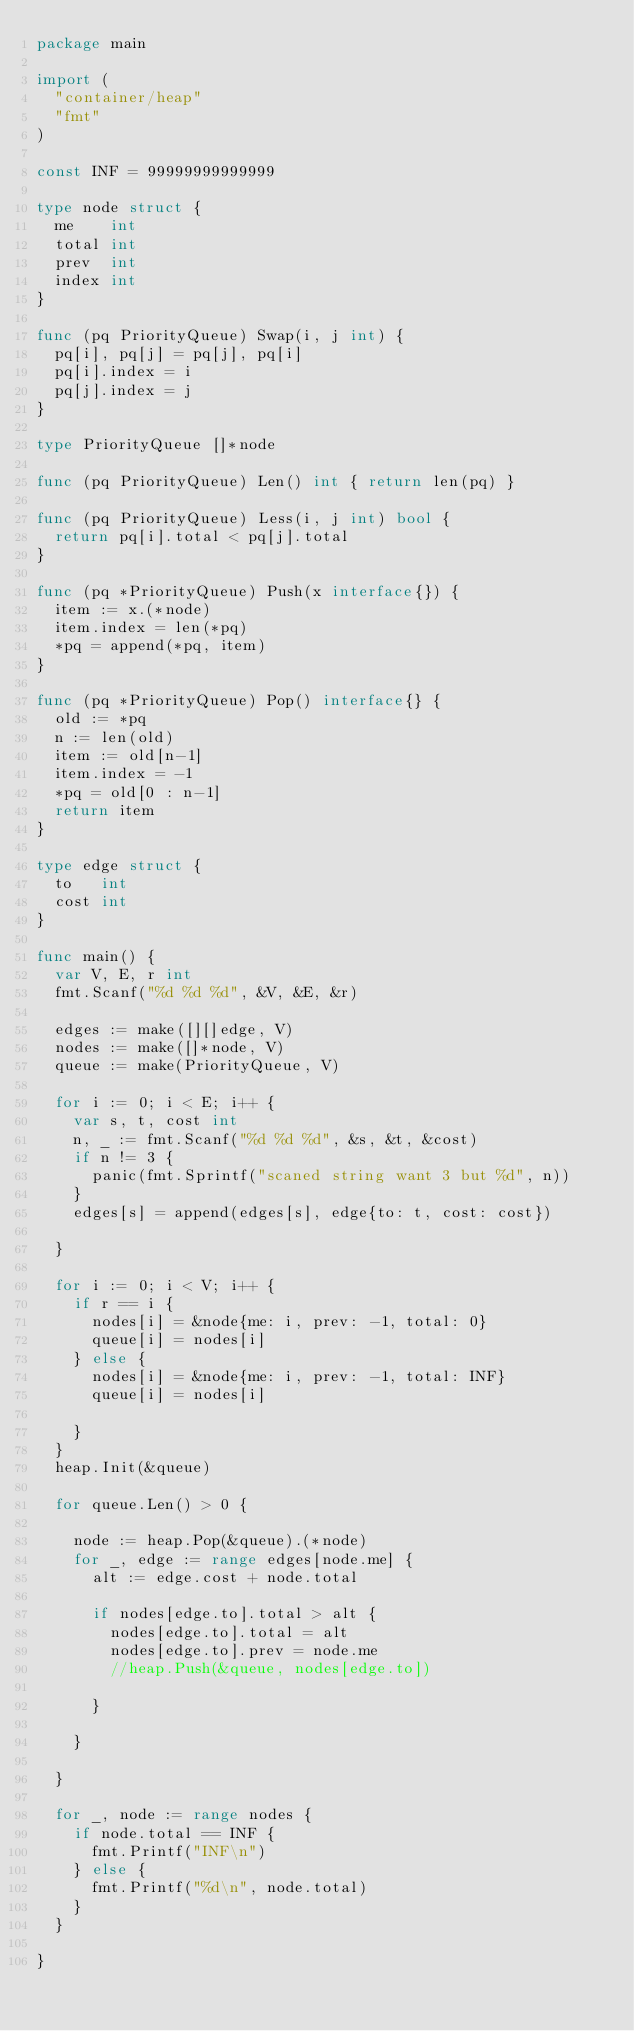<code> <loc_0><loc_0><loc_500><loc_500><_Go_>package main

import (
	"container/heap"
	"fmt"
)

const INF = 99999999999999

type node struct {
	me    int
	total int
	prev  int
	index int
}

func (pq PriorityQueue) Swap(i, j int) {
	pq[i], pq[j] = pq[j], pq[i]
	pq[i].index = i
	pq[j].index = j
}

type PriorityQueue []*node

func (pq PriorityQueue) Len() int { return len(pq) }

func (pq PriorityQueue) Less(i, j int) bool {
	return pq[i].total < pq[j].total
}

func (pq *PriorityQueue) Push(x interface{}) {
	item := x.(*node)
	item.index = len(*pq)
	*pq = append(*pq, item)
}

func (pq *PriorityQueue) Pop() interface{} {
	old := *pq
	n := len(old)
	item := old[n-1]
	item.index = -1
	*pq = old[0 : n-1]
	return item
}

type edge struct {
	to   int
	cost int
}

func main() {
	var V, E, r int
	fmt.Scanf("%d %d %d", &V, &E, &r)

	edges := make([][]edge, V)
	nodes := make([]*node, V)
	queue := make(PriorityQueue, V)

	for i := 0; i < E; i++ {
		var s, t, cost int
		n, _ := fmt.Scanf("%d %d %d", &s, &t, &cost)
		if n != 3 {
			panic(fmt.Sprintf("scaned string want 3 but %d", n))
		}
		edges[s] = append(edges[s], edge{to: t, cost: cost})

	}

	for i := 0; i < V; i++ {
		if r == i {
			nodes[i] = &node{me: i, prev: -1, total: 0}
			queue[i] = nodes[i]
		} else {
			nodes[i] = &node{me: i, prev: -1, total: INF}
			queue[i] = nodes[i]

		}
	}
	heap.Init(&queue)

	for queue.Len() > 0 {

		node := heap.Pop(&queue).(*node)
		for _, edge := range edges[node.me] {
			alt := edge.cost + node.total

			if nodes[edge.to].total > alt {
				nodes[edge.to].total = alt
				nodes[edge.to].prev = node.me
				//heap.Push(&queue, nodes[edge.to])

			}

		}

	}

	for _, node := range nodes {
		if node.total == INF {
			fmt.Printf("INF\n")
		} else {
			fmt.Printf("%d\n", node.total)
		}
	}

}

</code> 